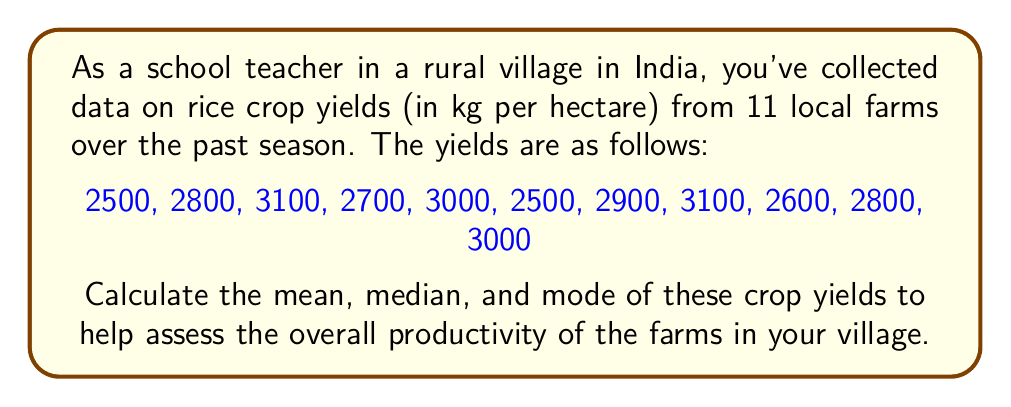Can you solve this math problem? Let's calculate the mean, median, and mode step-by-step:

1. Mean:
The mean is the average of all values in the dataset.

$$ \text{Mean} = \frac{\text{Sum of all values}}{\text{Number of values}} $$

Sum of all values: 2500 + 2800 + 3100 + 2700 + 3000 + 2500 + 2900 + 3100 + 2600 + 2800 + 3000 = 31000

Number of values: 11

$$ \text{Mean} = \frac{31000}{11} = 2818.18 \text{ kg/hectare} $$

2. Median:
The median is the middle value when the dataset is arranged in ascending or descending order.

Arranged dataset: 2500, 2500, 2600, 2700, 2800, 2800, 2900, 3000, 3000, 3100, 3100

With 11 values, the median is the 6th value.

Median = 2800 kg/hectare

3. Mode:
The mode is the value that appears most frequently in the dataset.

Frequency of each value:
2500: 2 times
2600: 1 time
2700: 1 time
2800: 2 times
2900: 1 time
3000: 2 times
3100: 2 times

There are multiple values (2500, 2800, 3000, and 3100) that appear with the highest frequency (2 times each). Therefore, this dataset is multimodal.

Mode = 2500, 2800, 3000, and 3100 kg/hectare
Answer: Mean: 2818.18 kg/hectare
Median: 2800 kg/hectare
Mode: 2500, 2800, 3000, and 3100 kg/hectare (multimodal) 